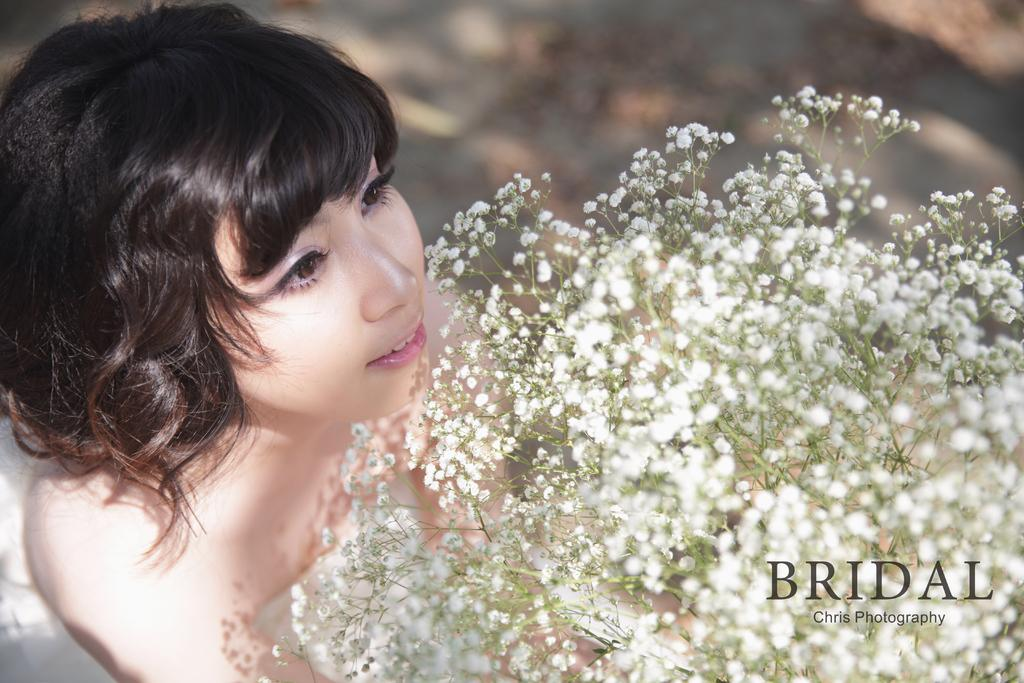Who is the main subject in the image? There is a lady in the image. What is the lady holding in the image? The lady is holding a bouquet. Is there any text present in the image? Yes, there is text in the bottom right corner of the image. How would you describe the background of the image? The background of the image is blurry. What type of steel is visible in the image? There is no steel present in the image. How does the lady's smile look in the image? The provided facts do not mention the lady's smile, so we cannot determine how it looks in the image. 